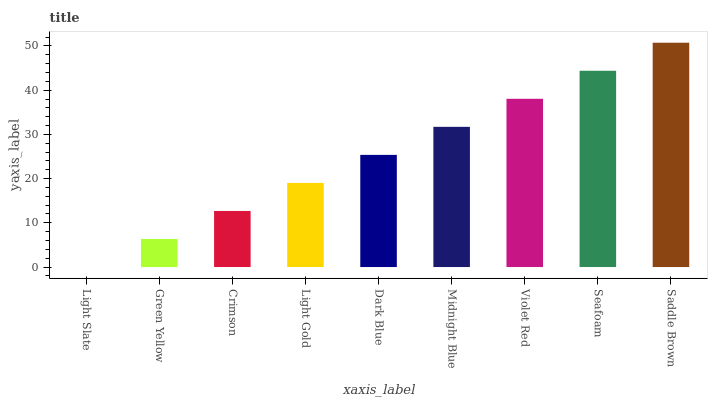Is Light Slate the minimum?
Answer yes or no. Yes. Is Saddle Brown the maximum?
Answer yes or no. Yes. Is Green Yellow the minimum?
Answer yes or no. No. Is Green Yellow the maximum?
Answer yes or no. No. Is Green Yellow greater than Light Slate?
Answer yes or no. Yes. Is Light Slate less than Green Yellow?
Answer yes or no. Yes. Is Light Slate greater than Green Yellow?
Answer yes or no. No. Is Green Yellow less than Light Slate?
Answer yes or no. No. Is Dark Blue the high median?
Answer yes or no. Yes. Is Dark Blue the low median?
Answer yes or no. Yes. Is Crimson the high median?
Answer yes or no. No. Is Midnight Blue the low median?
Answer yes or no. No. 